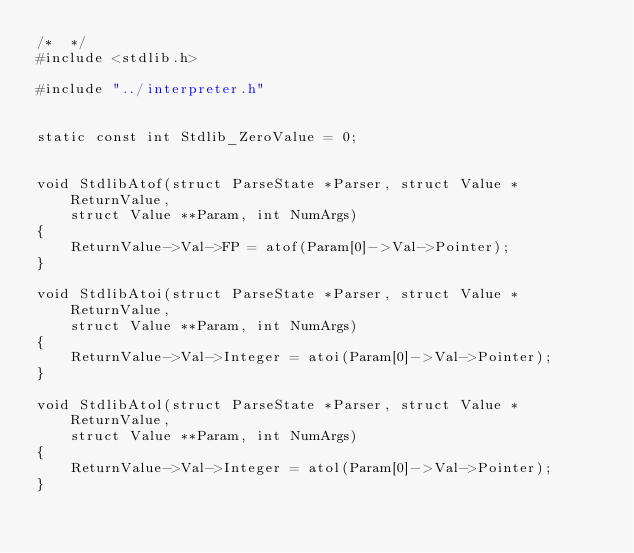<code> <loc_0><loc_0><loc_500><loc_500><_C_>/*  */
#include <stdlib.h>

#include "../interpreter.h"


static const int Stdlib_ZeroValue = 0;


void StdlibAtof(struct ParseState *Parser, struct Value *ReturnValue,
    struct Value **Param, int NumArgs)
{
    ReturnValue->Val->FP = atof(Param[0]->Val->Pointer);
}

void StdlibAtoi(struct ParseState *Parser, struct Value *ReturnValue,
    struct Value **Param, int NumArgs)
{
    ReturnValue->Val->Integer = atoi(Param[0]->Val->Pointer);
}

void StdlibAtol(struct ParseState *Parser, struct Value *ReturnValue,
    struct Value **Param, int NumArgs)
{
    ReturnValue->Val->Integer = atol(Param[0]->Val->Pointer);
}
</code> 